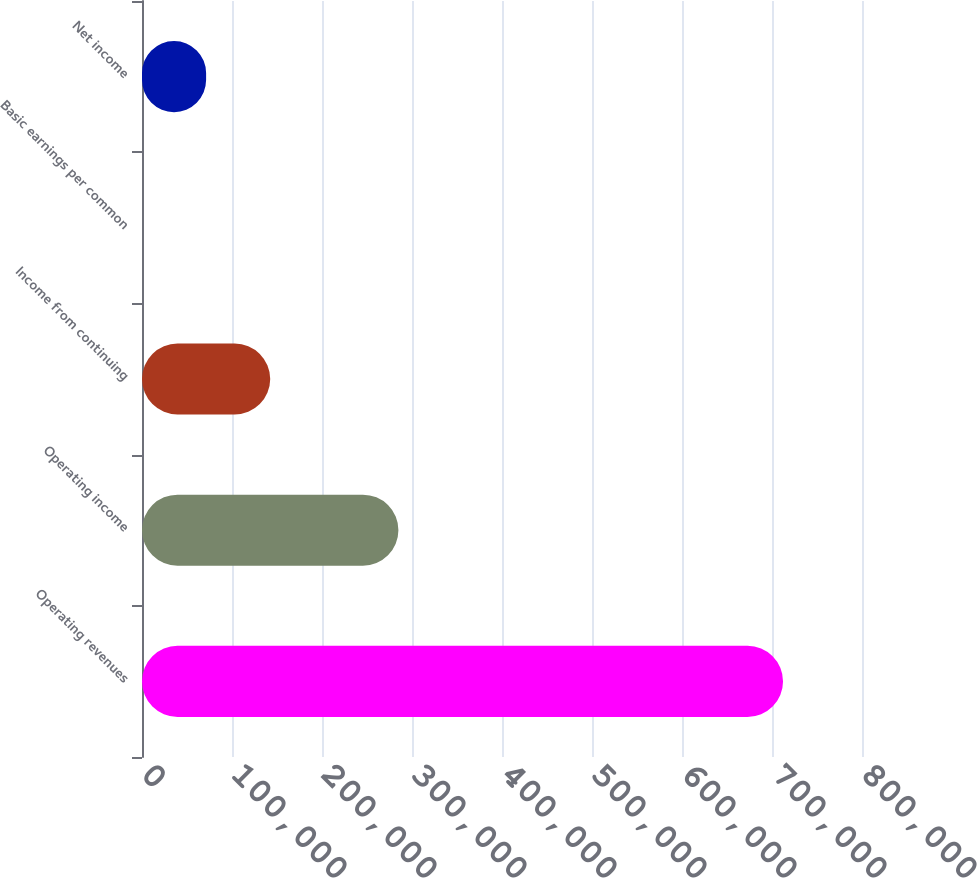Convert chart. <chart><loc_0><loc_0><loc_500><loc_500><bar_chart><fcel>Operating revenues<fcel>Operating income<fcel>Income from continuing<fcel>Basic earnings per common<fcel>Net income<nl><fcel>712260<fcel>284904<fcel>142452<fcel>0.33<fcel>71226.3<nl></chart> 